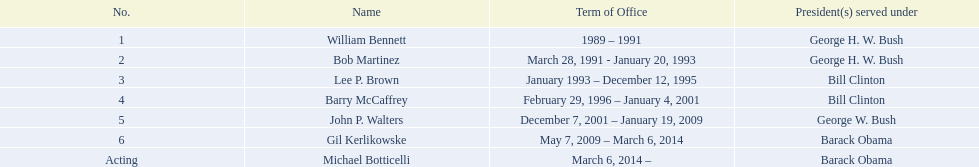What was the duration of bob martinez's tenure as a director? 2 years. 